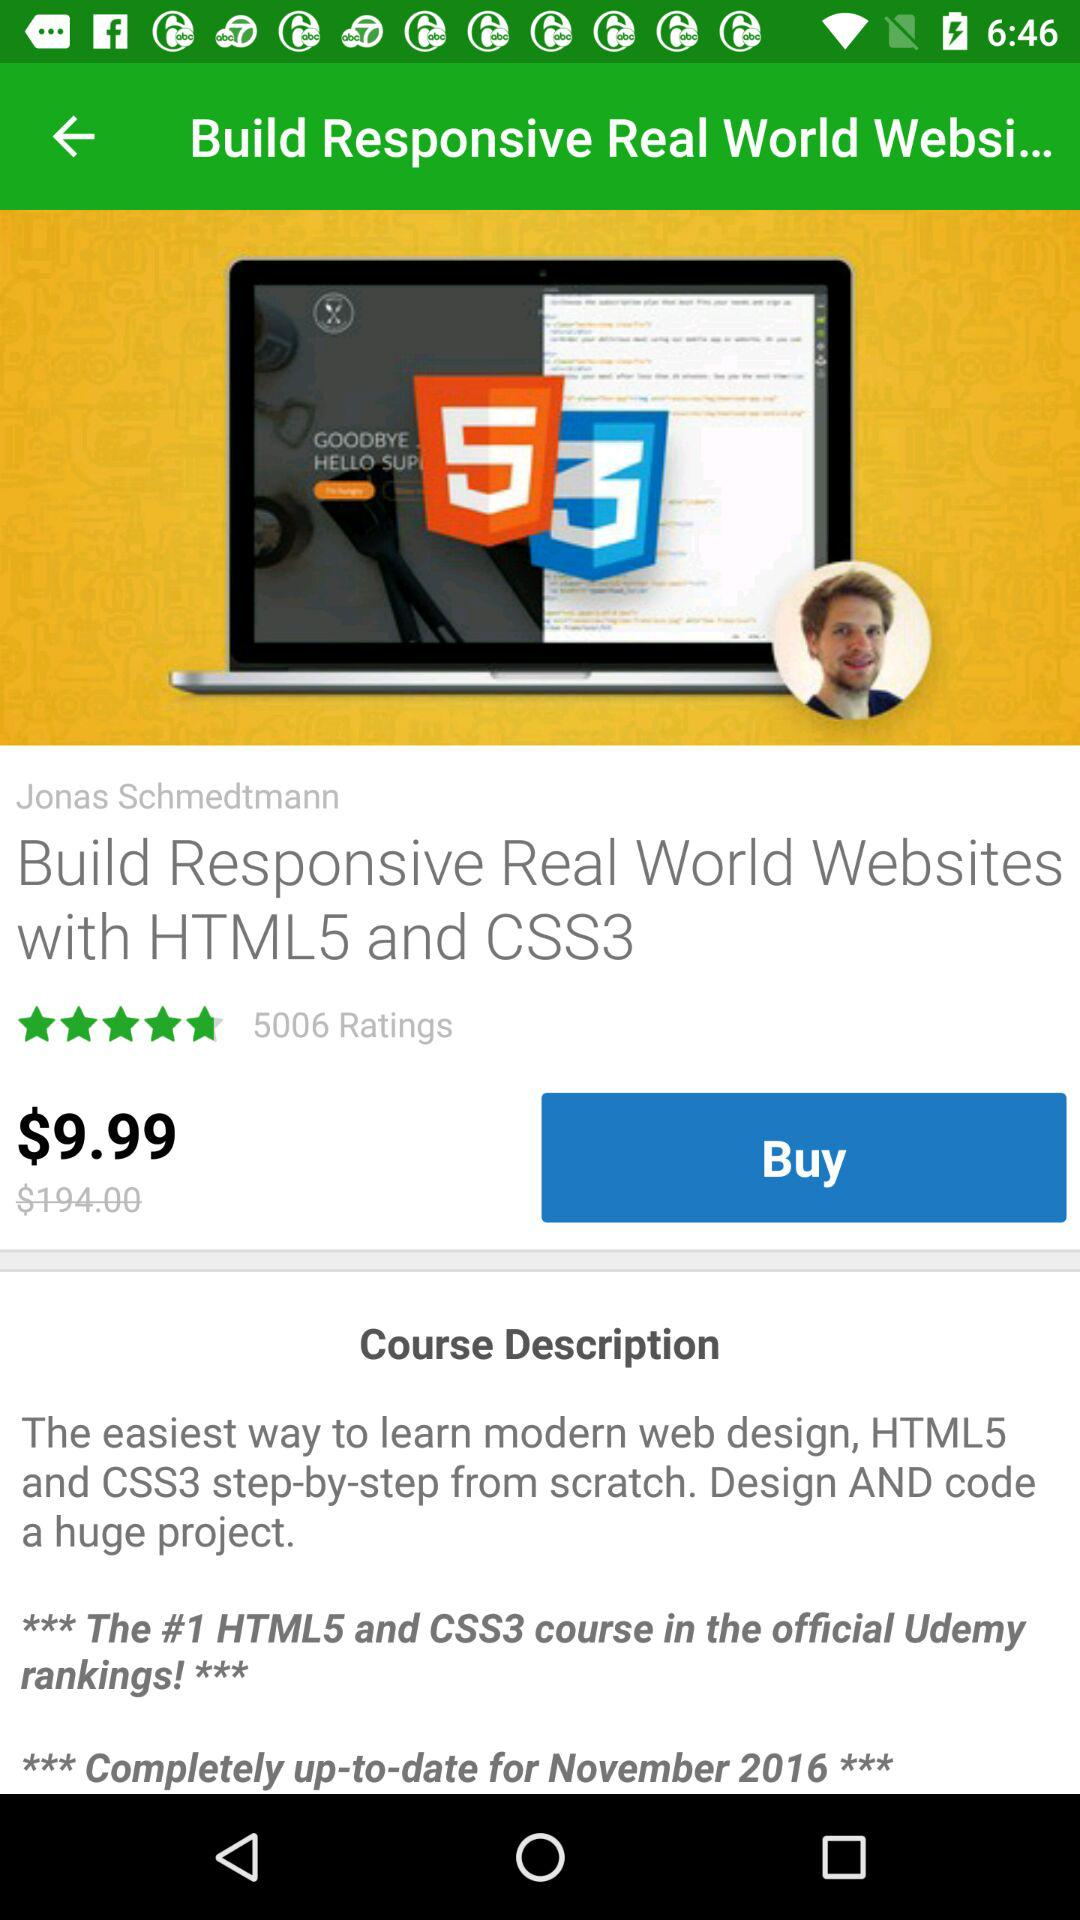How many stars did the course get?
When the provided information is insufficient, respond with <no answer>. <no answer> 